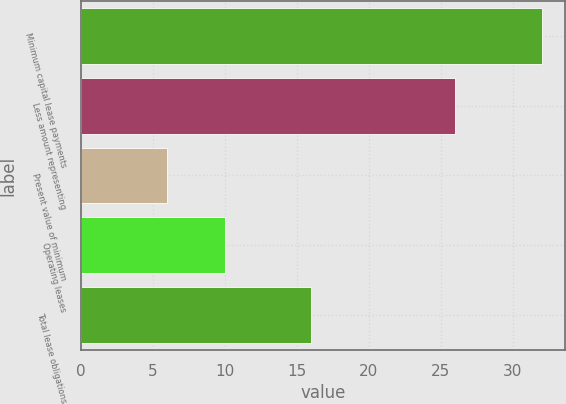Convert chart. <chart><loc_0><loc_0><loc_500><loc_500><bar_chart><fcel>Minimum capital lease payments<fcel>Less amount representing<fcel>Present value of minimum<fcel>Operating leases<fcel>Total lease obligations<nl><fcel>32<fcel>26<fcel>6<fcel>10<fcel>16<nl></chart> 